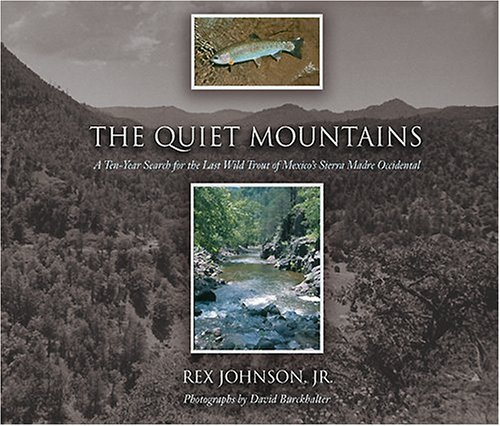Who wrote this book? Rex Johnson Jr. is the author of the book depicted in the image. 